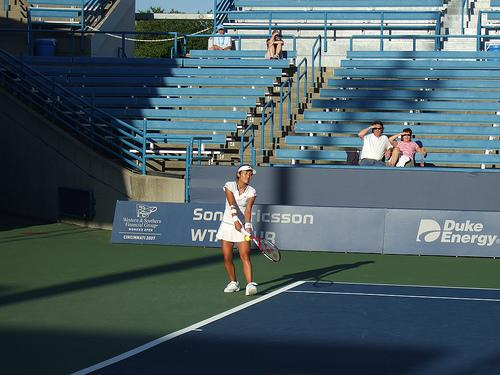Identify the key elements related to the tennis court in the image. Elements include a blue and green tennis court, a dull blue wall, and a white line where the woman stands. Mention the primary action being performed by the sportsperson in the image. An Asian woman is playing tennis, holding a ball and a tennis racket in her hand. Point out any notable elements related to the audience area in the image. There are blue audience bleachers, blue handrails on stairs, and people watching the tennis player in action. Capture the essence of the image in one sentence. A woman competes in tennis, captivating her audience, while surrounded by a predominantly blue setting. How do the spectators in the stands appear in relation to the tennis player? The spectators look towards the tennis player with interest, some shading their eyes with their right hands. Describe the color scheme dominating the image. The image features a predominance of blue tones, from the court, wall, and seating, to the Duke Energy sign. Mention any distinctive clothing or accessories worn by the main subject in the image. The tennis player wears a white visor, a white tennis skirt, and has two white objects around her right arm. Briefly describe the most prominent visual aspect in the image. A female tennis player is in action, wearing a white tennis skirt and holding a ball and a racket. List the various items and people in the image associated with the tennis game. Asian woman playing, tennis ball, racket, court, shadow on a court, white line, and part of a banner. What is the overall mood of the spectators in the image? The spectators are engaged and attentive, with some shielding their eyes with their hands. 